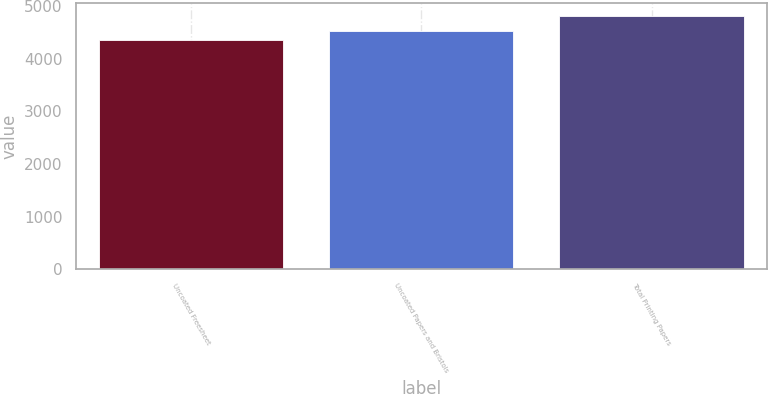Convert chart. <chart><loc_0><loc_0><loc_500><loc_500><bar_chart><fcel>Uncoated Freesheet<fcel>Uncoated Papers and Bristols<fcel>Total Printing Papers<nl><fcel>4362<fcel>4527<fcel>4812<nl></chart> 